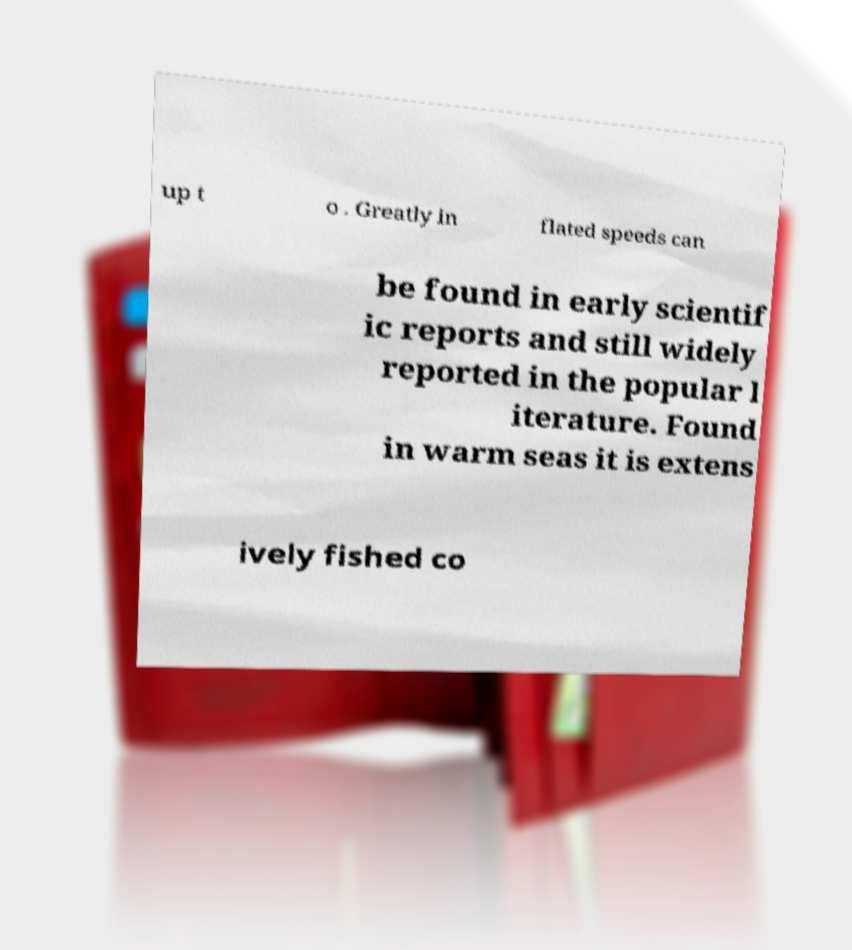For documentation purposes, I need the text within this image transcribed. Could you provide that? up t o . Greatly in flated speeds can be found in early scientif ic reports and still widely reported in the popular l iterature. Found in warm seas it is extens ively fished co 